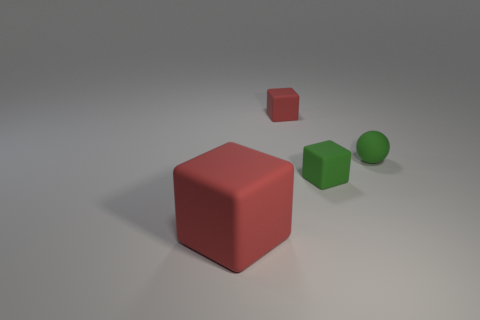There is a large object; are there any red blocks to the right of it?
Your answer should be compact. Yes. There is a large rubber block; is it the same color as the tiny rubber thing to the right of the tiny green rubber cube?
Offer a very short reply. No. What color is the small matte sphere right of the red thing that is in front of the small object that is in front of the small green rubber ball?
Offer a very short reply. Green. Are there any large red rubber objects of the same shape as the small red rubber object?
Provide a short and direct response. Yes. What color is the other matte block that is the same size as the green matte block?
Make the answer very short. Red. What is the material of the red thing in front of the small red object?
Offer a terse response. Rubber. There is a green thing to the left of the small sphere; is its shape the same as the red matte thing that is in front of the tiny green matte block?
Make the answer very short. Yes. Are there an equal number of large red objects in front of the small red rubber block and large red rubber objects?
Your response must be concise. Yes. What number of small red blocks are the same material as the big red object?
Give a very brief answer. 1. What color is the ball that is the same material as the small red thing?
Your answer should be compact. Green. 